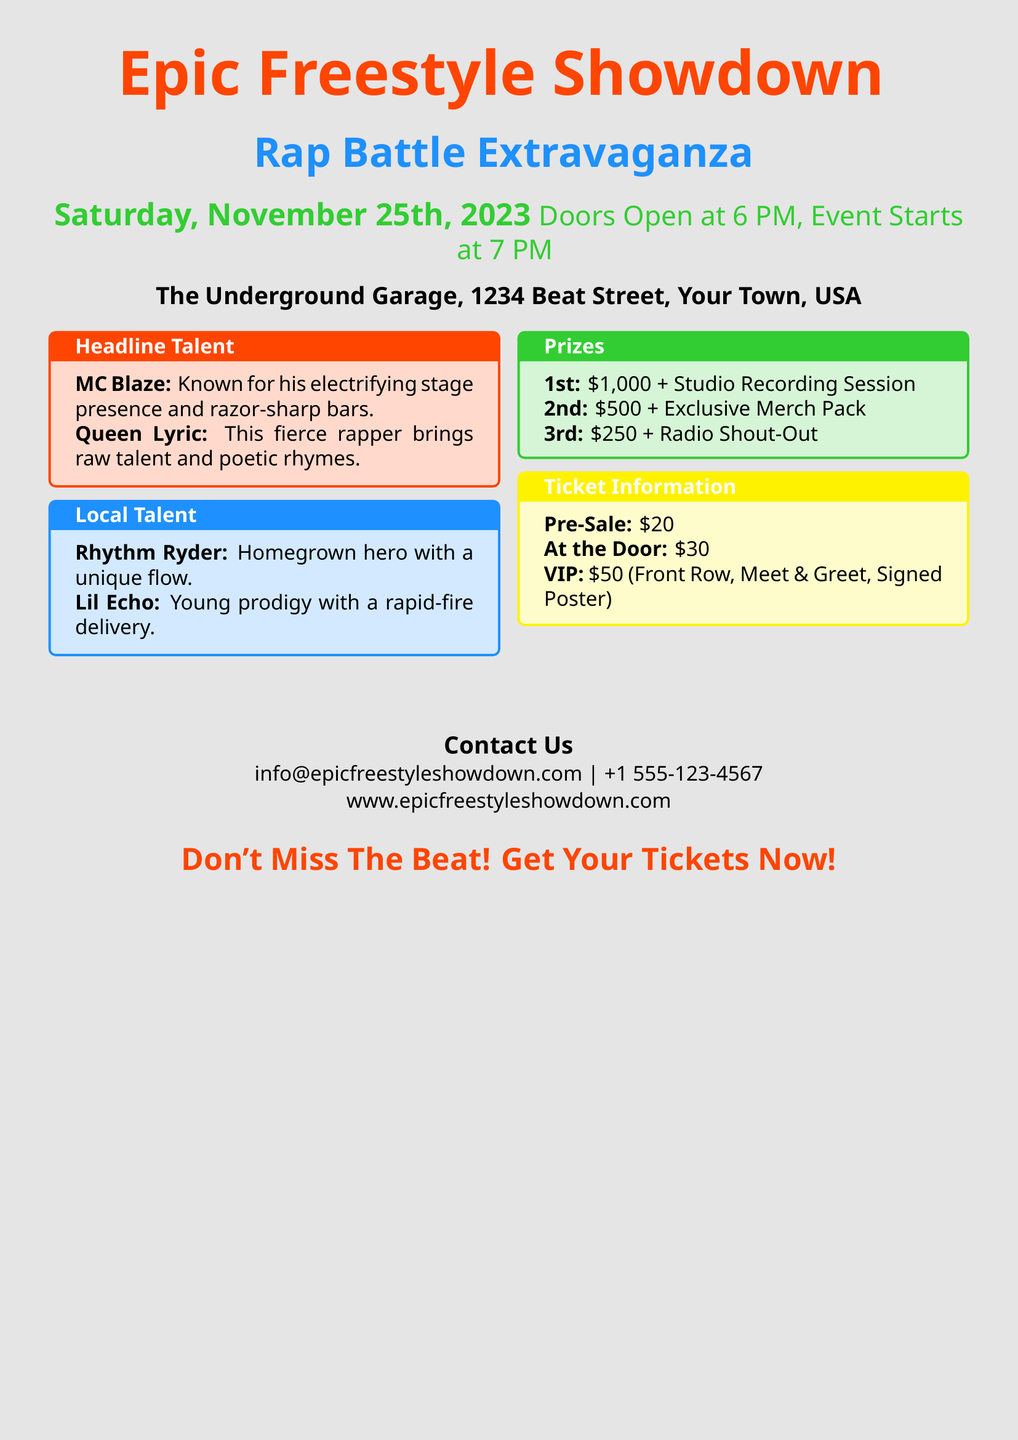What date is the event taking place? The event is scheduled for Saturday, November 25th, 2023.
Answer: November 25th, 2023 What is the location of the event? The event will be held at The Underground Garage, 1234 Beat Street, Your Town, USA.
Answer: The Underground Garage, 1234 Beat Street, Your Town, USA Who is one of the headline talents? The document lists MC Blaze and Queen Lyric as headline talents.
Answer: MC Blaze What are the prizes for the rap battle? The document specifies the prizes for the first, second, and third places.
Answer: $1,000 + Studio Recording Session What is the price of a VIP ticket? The VIP ticket is priced at $50 and includes specific benefits.
Answer: $50 How much does a pre-sale ticket cost? The pre-sale ticket price is clearly mentioned in the document.
Answer: $20 What time does the event start? The document states the commencement time of the event.
Answer: 7 PM What is the contact email for inquiries? The document provides a specific email address for contact regarding the event.
Answer: info@epicfreestyleshowdown.com What is unique about the local talent? The local talent has been described in a unique way that highlights their qualities.
Answer: Homegrown hero with a unique flow 